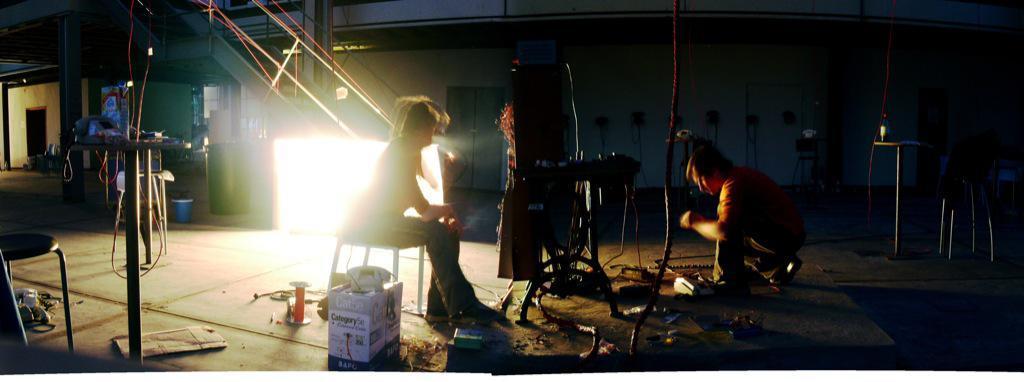Describe this image in one or two sentences. In this picture I can see two persons, there are chairs, there are some items on the tables, there are cables, cardboard box, there is a landline phone and some other objects, and in the background there are doors and a wall. 